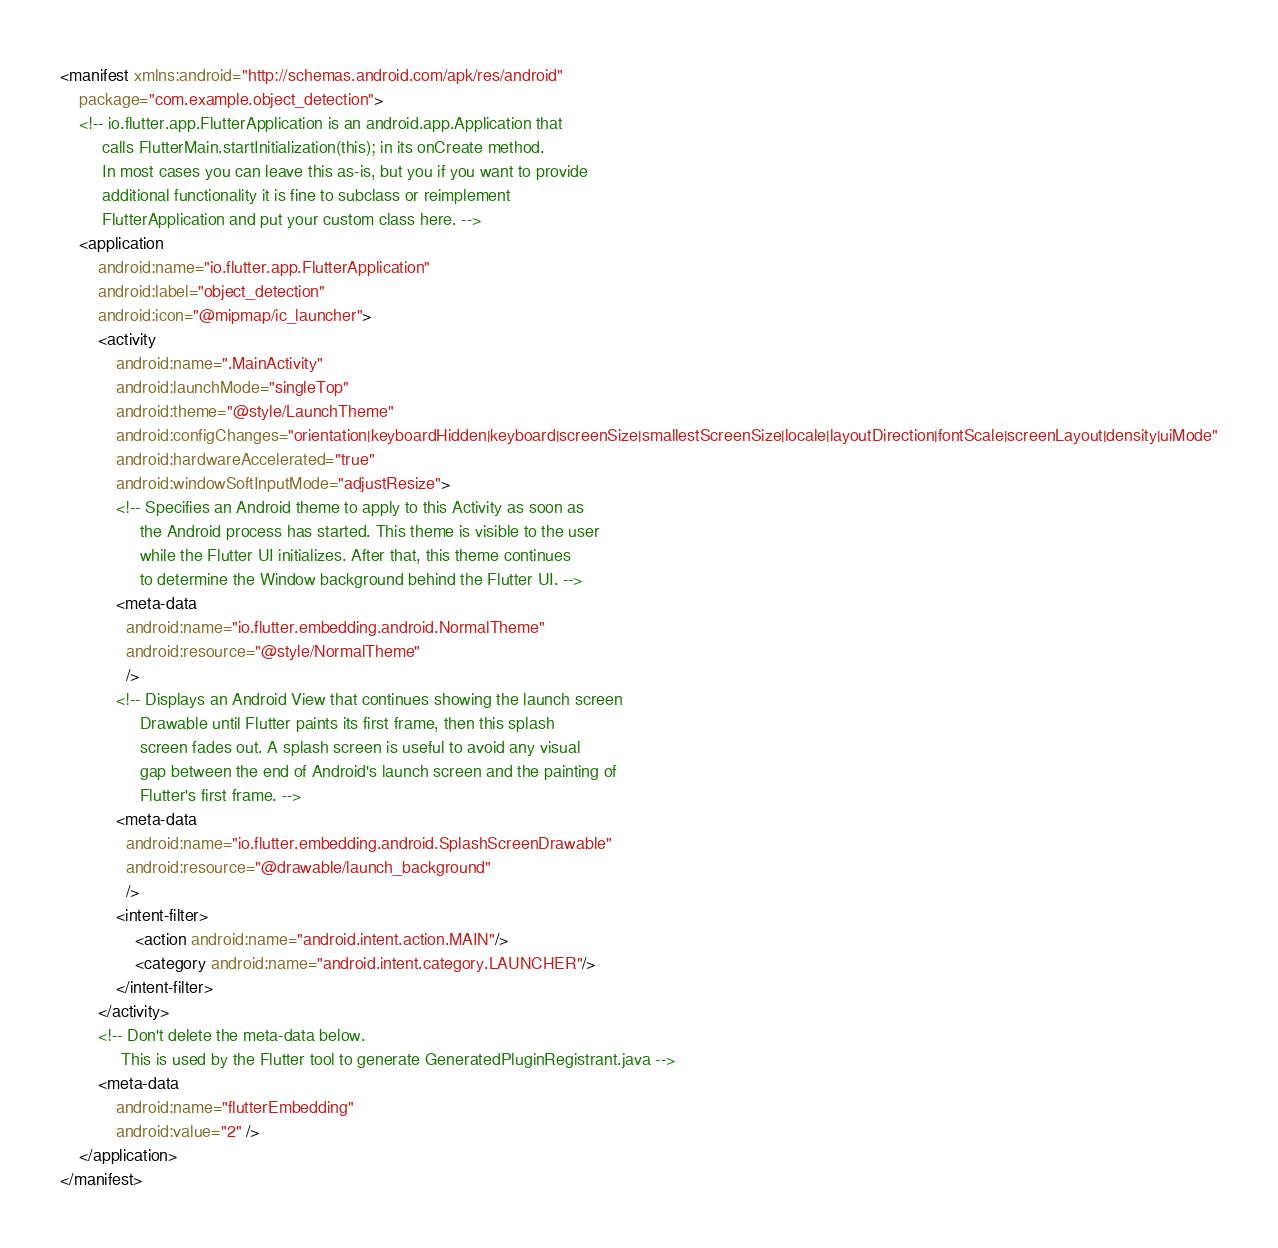Convert code to text. <code><loc_0><loc_0><loc_500><loc_500><_XML_><manifest xmlns:android="http://schemas.android.com/apk/res/android"
    package="com.example.object_detection">
    <!-- io.flutter.app.FlutterApplication is an android.app.Application that
         calls FlutterMain.startInitialization(this); in its onCreate method.
         In most cases you can leave this as-is, but you if you want to provide
         additional functionality it is fine to subclass or reimplement
         FlutterApplication and put your custom class here. -->
    <application
        android:name="io.flutter.app.FlutterApplication"
        android:label="object_detection"
        android:icon="@mipmap/ic_launcher">
        <activity
            android:name=".MainActivity"
            android:launchMode="singleTop"
            android:theme="@style/LaunchTheme"
            android:configChanges="orientation|keyboardHidden|keyboard|screenSize|smallestScreenSize|locale|layoutDirection|fontScale|screenLayout|density|uiMode"
            android:hardwareAccelerated="true"
            android:windowSoftInputMode="adjustResize">
            <!-- Specifies an Android theme to apply to this Activity as soon as
                 the Android process has started. This theme is visible to the user
                 while the Flutter UI initializes. After that, this theme continues
                 to determine the Window background behind the Flutter UI. -->
            <meta-data
              android:name="io.flutter.embedding.android.NormalTheme"
              android:resource="@style/NormalTheme"
              />
            <!-- Displays an Android View that continues showing the launch screen
                 Drawable until Flutter paints its first frame, then this splash
                 screen fades out. A splash screen is useful to avoid any visual
                 gap between the end of Android's launch screen and the painting of
                 Flutter's first frame. -->
            <meta-data
              android:name="io.flutter.embedding.android.SplashScreenDrawable"
              android:resource="@drawable/launch_background"
              />
            <intent-filter>
                <action android:name="android.intent.action.MAIN"/>
                <category android:name="android.intent.category.LAUNCHER"/>
            </intent-filter>
        </activity>
        <!-- Don't delete the meta-data below.
             This is used by the Flutter tool to generate GeneratedPluginRegistrant.java -->
        <meta-data
            android:name="flutterEmbedding"
            android:value="2" />
    </application>
</manifest>
</code> 